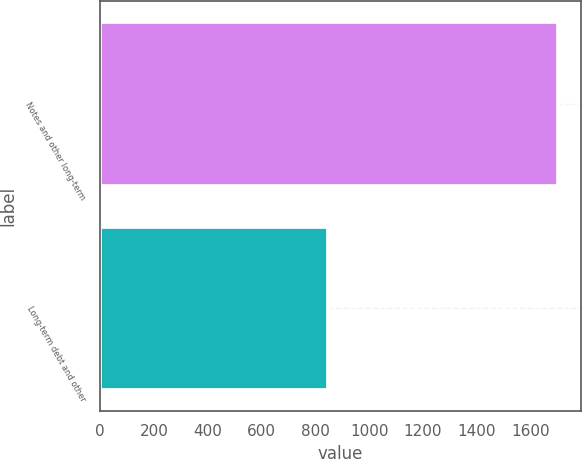<chart> <loc_0><loc_0><loc_500><loc_500><bar_chart><fcel>Notes and other long-term<fcel>Long-term debt and other<nl><fcel>1702<fcel>848<nl></chart> 